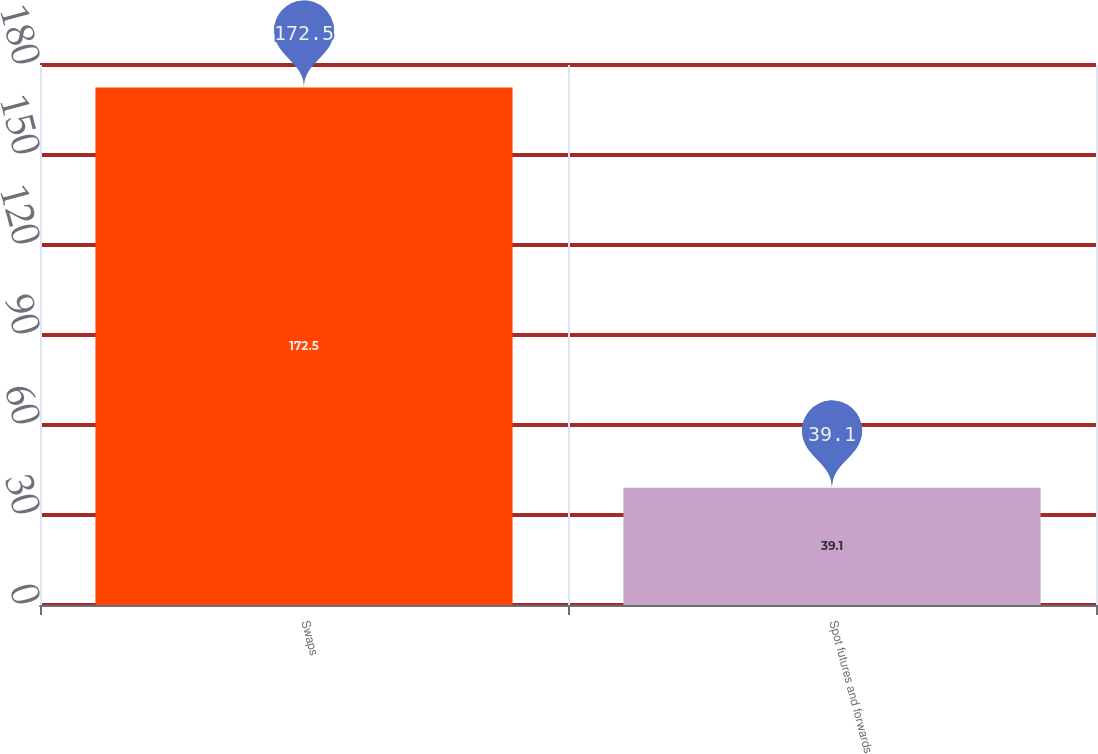<chart> <loc_0><loc_0><loc_500><loc_500><bar_chart><fcel>Swaps<fcel>Spot futures and forwards<nl><fcel>172.5<fcel>39.1<nl></chart> 